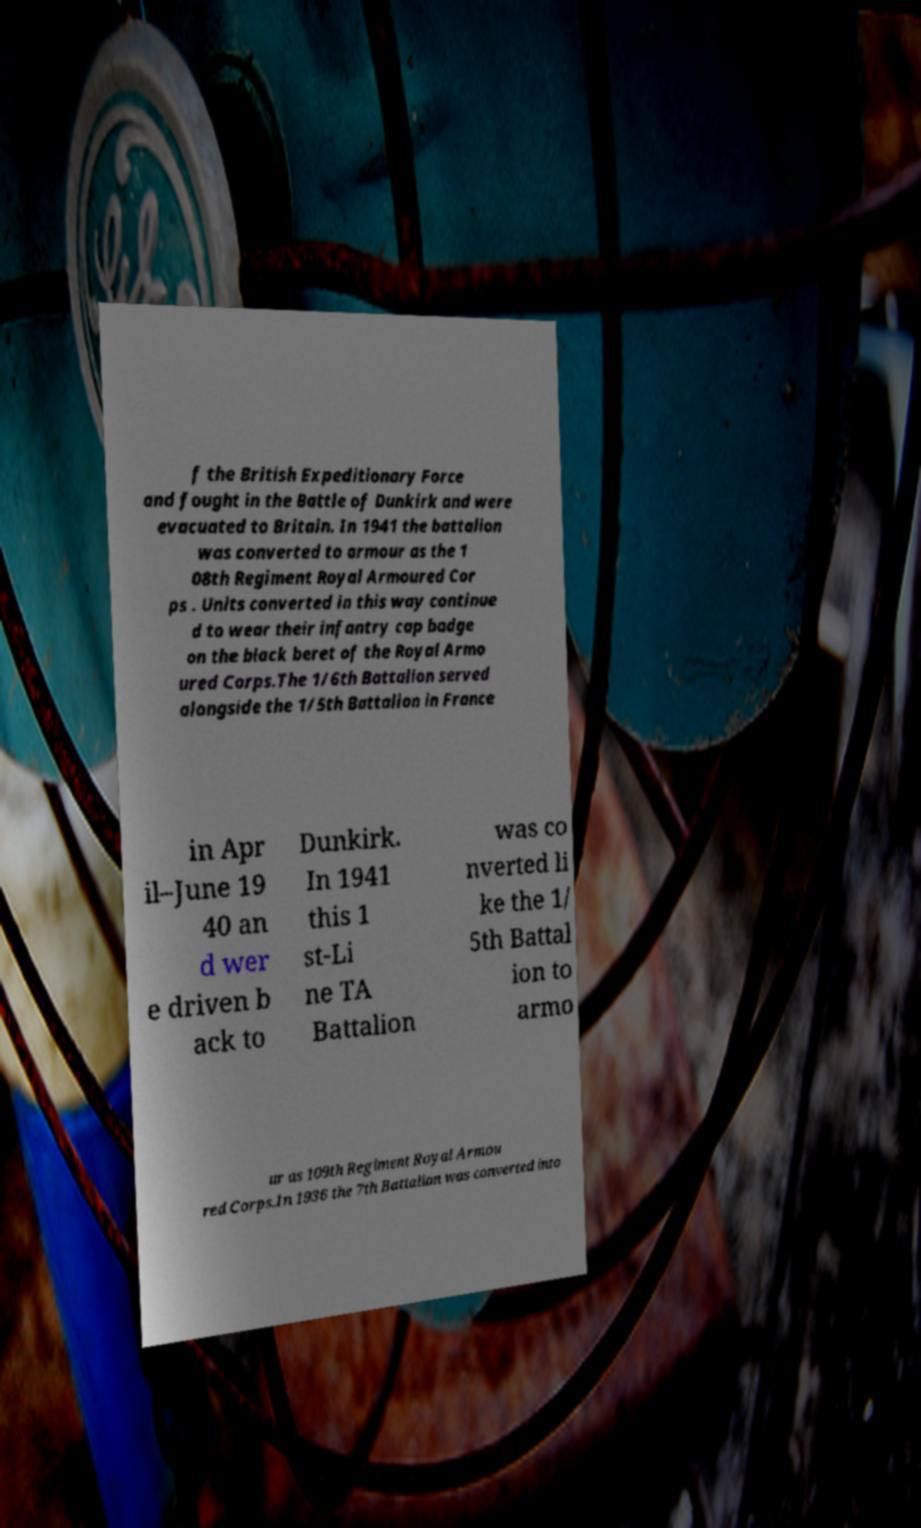Could you extract and type out the text from this image? f the British Expeditionary Force and fought in the Battle of Dunkirk and were evacuated to Britain. In 1941 the battalion was converted to armour as the 1 08th Regiment Royal Armoured Cor ps . Units converted in this way continue d to wear their infantry cap badge on the black beret of the Royal Armo ured Corps.The 1/6th Battalion served alongside the 1/5th Battalion in France in Apr il–June 19 40 an d wer e driven b ack to Dunkirk. In 1941 this 1 st-Li ne TA Battalion was co nverted li ke the 1/ 5th Battal ion to armo ur as 109th Regiment Royal Armou red Corps.In 1936 the 7th Battalion was converted into 